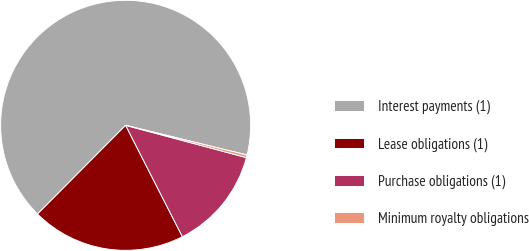Convert chart. <chart><loc_0><loc_0><loc_500><loc_500><pie_chart><fcel>Interest payments (1)<fcel>Lease obligations (1)<fcel>Purchase obligations (1)<fcel>Minimum royalty obligations<nl><fcel>66.37%<fcel>19.95%<fcel>13.34%<fcel>0.34%<nl></chart> 